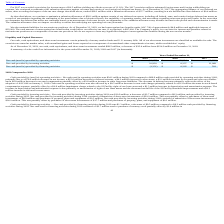From Immersion's financial document, What was the cash, cash equivalents and short-term investments in 2019 and 2018? The document shows two values: $89.5 million and $124.9 million. From the document: "sh equivalents, and short-term investments totaled $89.5 million, a decrease of $35.4 million from $124.9 million on December 31, 2018. ed $89.5 milli..." Also, What affected the decrease in deferred revenue? the effect of the adoption of ASC 606 on January 1, 2018.. The document states: "he decrease in deferred revenue primarily reflects the effect of the adoption of ASC 606 on January 1, 2018. Cash used in operating activities was als..." Also, What was the Net cash (used in) provided by operating activities in 2019? According to the financial document, $(34,099) (in thousands). The relevant text states: "cash (used in) provided by operating activities $ (34,099) $ 69,924 $ (43,829)..." Additionally, In which year was Net cash provided by investing activities less than 10,000 thousands? According to the financial document, 2018. The relevant text states: "2019 2018 2017..." Also, can you calculate: What was the change in the Net cash (used in) provided by operating activities from 2018 to 2019? Based on the calculation: -34,099 - 69,924, the result is -104023 (in thousands). This is based on the information: "in) provided by operating activities $ (34,099) $ 69,924 $ (43,829) ash (used in) provided by operating activities $ (34,099) $ 69,924 $ (43,829)..." The key data points involved are: 34,099, 69,924. Also, can you calculate: What was the average Net cash provided by investing activities from 2017-2019? To answer this question, I need to perform calculations using the financial data. The calculation is: (10,920 + 8,237 + 11,068) / 3, which equals 10075 (in thousands). This is based on the information: "ovided by investing activities $ 10,920 $ 8,237 $ 11,068 cash provided by investing activities $ 10,920 $ 8,237 $ 11,068 Net cash provided by investing activities $ 10,920 $ 8,237 $ 11,068..." The key data points involved are: 10,920, 11,068, 8,237. 